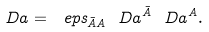Convert formula to latex. <formula><loc_0><loc_0><loc_500><loc_500>\ D a = \ e p s _ { \bar { A } A } \ D a ^ { \bar { A } } \ D a ^ { A } .</formula> 